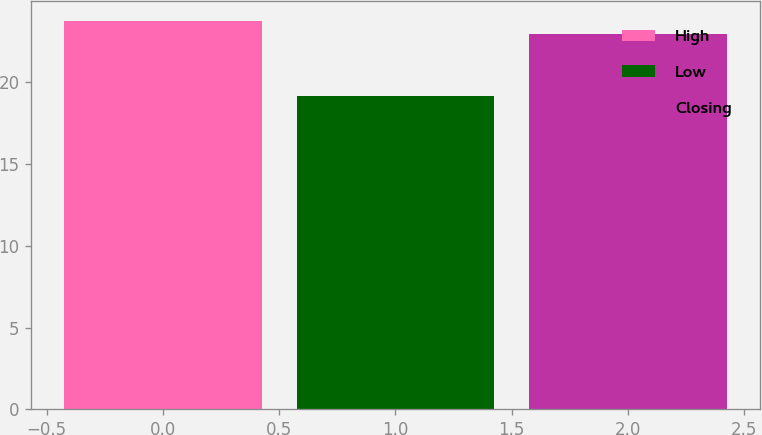Convert chart to OTSL. <chart><loc_0><loc_0><loc_500><loc_500><bar_chart><fcel>High<fcel>Low<fcel>Closing<nl><fcel>23.78<fcel>19.15<fcel>22.99<nl></chart> 